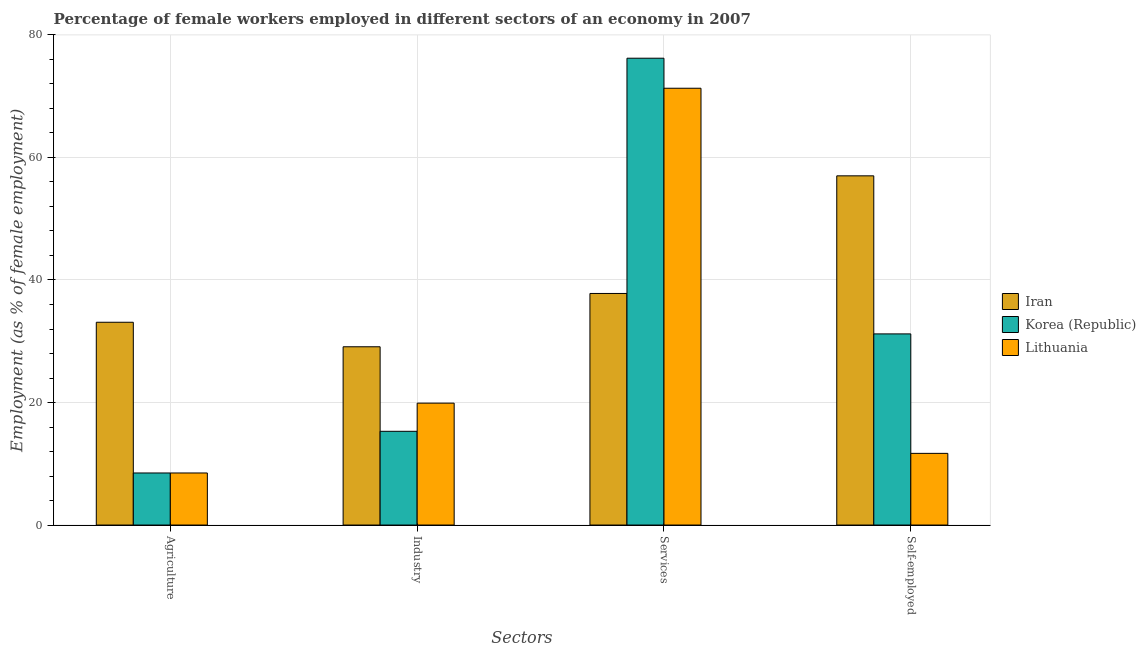How many different coloured bars are there?
Your answer should be compact. 3. Are the number of bars per tick equal to the number of legend labels?
Your answer should be compact. Yes. How many bars are there on the 1st tick from the left?
Offer a very short reply. 3. What is the label of the 4th group of bars from the left?
Provide a short and direct response. Self-employed. What is the percentage of female workers in agriculture in Lithuania?
Your response must be concise. 8.5. Across all countries, what is the maximum percentage of female workers in industry?
Offer a very short reply. 29.1. Across all countries, what is the minimum percentage of female workers in agriculture?
Make the answer very short. 8.5. What is the total percentage of female workers in industry in the graph?
Ensure brevity in your answer.  64.3. What is the difference between the percentage of self employed female workers in Korea (Republic) and that in Lithuania?
Offer a very short reply. 19.5. What is the difference between the percentage of female workers in industry in Lithuania and the percentage of female workers in services in Iran?
Make the answer very short. -17.9. What is the average percentage of female workers in industry per country?
Offer a terse response. 21.43. What is the difference between the percentage of female workers in services and percentage of female workers in industry in Korea (Republic)?
Provide a succinct answer. 60.9. What is the ratio of the percentage of female workers in industry in Lithuania to that in Iran?
Give a very brief answer. 0.68. What is the difference between the highest and the second highest percentage of female workers in industry?
Keep it short and to the point. 9.2. What is the difference between the highest and the lowest percentage of self employed female workers?
Your response must be concise. 45.3. Is the sum of the percentage of self employed female workers in Iran and Lithuania greater than the maximum percentage of female workers in agriculture across all countries?
Your response must be concise. Yes. Is it the case that in every country, the sum of the percentage of self employed female workers and percentage of female workers in industry is greater than the sum of percentage of female workers in agriculture and percentage of female workers in services?
Your answer should be very brief. No. What does the 1st bar from the left in Industry represents?
Keep it short and to the point. Iran. What does the 1st bar from the right in Services represents?
Give a very brief answer. Lithuania. Is it the case that in every country, the sum of the percentage of female workers in agriculture and percentage of female workers in industry is greater than the percentage of female workers in services?
Give a very brief answer. No. How many bars are there?
Offer a terse response. 12. How many countries are there in the graph?
Make the answer very short. 3. What is the difference between two consecutive major ticks on the Y-axis?
Ensure brevity in your answer.  20. Does the graph contain any zero values?
Offer a terse response. No. Where does the legend appear in the graph?
Keep it short and to the point. Center right. How many legend labels are there?
Your answer should be very brief. 3. How are the legend labels stacked?
Your response must be concise. Vertical. What is the title of the graph?
Offer a terse response. Percentage of female workers employed in different sectors of an economy in 2007. What is the label or title of the X-axis?
Provide a short and direct response. Sectors. What is the label or title of the Y-axis?
Offer a terse response. Employment (as % of female employment). What is the Employment (as % of female employment) in Iran in Agriculture?
Give a very brief answer. 33.1. What is the Employment (as % of female employment) of Korea (Republic) in Agriculture?
Give a very brief answer. 8.5. What is the Employment (as % of female employment) in Iran in Industry?
Keep it short and to the point. 29.1. What is the Employment (as % of female employment) in Korea (Republic) in Industry?
Your answer should be very brief. 15.3. What is the Employment (as % of female employment) of Lithuania in Industry?
Provide a succinct answer. 19.9. What is the Employment (as % of female employment) in Iran in Services?
Your answer should be compact. 37.8. What is the Employment (as % of female employment) in Korea (Republic) in Services?
Your response must be concise. 76.2. What is the Employment (as % of female employment) in Lithuania in Services?
Give a very brief answer. 71.3. What is the Employment (as % of female employment) of Iran in Self-employed?
Give a very brief answer. 57. What is the Employment (as % of female employment) in Korea (Republic) in Self-employed?
Your answer should be very brief. 31.2. What is the Employment (as % of female employment) in Lithuania in Self-employed?
Give a very brief answer. 11.7. Across all Sectors, what is the maximum Employment (as % of female employment) of Korea (Republic)?
Your answer should be very brief. 76.2. Across all Sectors, what is the maximum Employment (as % of female employment) of Lithuania?
Offer a very short reply. 71.3. Across all Sectors, what is the minimum Employment (as % of female employment) of Iran?
Give a very brief answer. 29.1. Across all Sectors, what is the minimum Employment (as % of female employment) of Lithuania?
Provide a short and direct response. 8.5. What is the total Employment (as % of female employment) in Iran in the graph?
Offer a terse response. 157. What is the total Employment (as % of female employment) in Korea (Republic) in the graph?
Your answer should be very brief. 131.2. What is the total Employment (as % of female employment) of Lithuania in the graph?
Offer a terse response. 111.4. What is the difference between the Employment (as % of female employment) of Iran in Agriculture and that in Industry?
Ensure brevity in your answer.  4. What is the difference between the Employment (as % of female employment) of Korea (Republic) in Agriculture and that in Industry?
Provide a succinct answer. -6.8. What is the difference between the Employment (as % of female employment) in Iran in Agriculture and that in Services?
Provide a short and direct response. -4.7. What is the difference between the Employment (as % of female employment) of Korea (Republic) in Agriculture and that in Services?
Offer a terse response. -67.7. What is the difference between the Employment (as % of female employment) in Lithuania in Agriculture and that in Services?
Provide a succinct answer. -62.8. What is the difference between the Employment (as % of female employment) of Iran in Agriculture and that in Self-employed?
Your response must be concise. -23.9. What is the difference between the Employment (as % of female employment) of Korea (Republic) in Agriculture and that in Self-employed?
Provide a succinct answer. -22.7. What is the difference between the Employment (as % of female employment) of Lithuania in Agriculture and that in Self-employed?
Ensure brevity in your answer.  -3.2. What is the difference between the Employment (as % of female employment) of Korea (Republic) in Industry and that in Services?
Your response must be concise. -60.9. What is the difference between the Employment (as % of female employment) of Lithuania in Industry and that in Services?
Offer a very short reply. -51.4. What is the difference between the Employment (as % of female employment) in Iran in Industry and that in Self-employed?
Provide a succinct answer. -27.9. What is the difference between the Employment (as % of female employment) of Korea (Republic) in Industry and that in Self-employed?
Provide a short and direct response. -15.9. What is the difference between the Employment (as % of female employment) in Iran in Services and that in Self-employed?
Provide a succinct answer. -19.2. What is the difference between the Employment (as % of female employment) of Lithuania in Services and that in Self-employed?
Provide a succinct answer. 59.6. What is the difference between the Employment (as % of female employment) in Iran in Agriculture and the Employment (as % of female employment) in Lithuania in Industry?
Your answer should be very brief. 13.2. What is the difference between the Employment (as % of female employment) of Korea (Republic) in Agriculture and the Employment (as % of female employment) of Lithuania in Industry?
Keep it short and to the point. -11.4. What is the difference between the Employment (as % of female employment) of Iran in Agriculture and the Employment (as % of female employment) of Korea (Republic) in Services?
Offer a terse response. -43.1. What is the difference between the Employment (as % of female employment) of Iran in Agriculture and the Employment (as % of female employment) of Lithuania in Services?
Provide a short and direct response. -38.2. What is the difference between the Employment (as % of female employment) of Korea (Republic) in Agriculture and the Employment (as % of female employment) of Lithuania in Services?
Provide a short and direct response. -62.8. What is the difference between the Employment (as % of female employment) in Iran in Agriculture and the Employment (as % of female employment) in Lithuania in Self-employed?
Make the answer very short. 21.4. What is the difference between the Employment (as % of female employment) in Iran in Industry and the Employment (as % of female employment) in Korea (Republic) in Services?
Your answer should be compact. -47.1. What is the difference between the Employment (as % of female employment) in Iran in Industry and the Employment (as % of female employment) in Lithuania in Services?
Your answer should be compact. -42.2. What is the difference between the Employment (as % of female employment) in Korea (Republic) in Industry and the Employment (as % of female employment) in Lithuania in Services?
Make the answer very short. -56. What is the difference between the Employment (as % of female employment) in Iran in Industry and the Employment (as % of female employment) in Korea (Republic) in Self-employed?
Provide a short and direct response. -2.1. What is the difference between the Employment (as % of female employment) in Iran in Services and the Employment (as % of female employment) in Lithuania in Self-employed?
Your answer should be very brief. 26.1. What is the difference between the Employment (as % of female employment) in Korea (Republic) in Services and the Employment (as % of female employment) in Lithuania in Self-employed?
Offer a very short reply. 64.5. What is the average Employment (as % of female employment) of Iran per Sectors?
Ensure brevity in your answer.  39.25. What is the average Employment (as % of female employment) of Korea (Republic) per Sectors?
Offer a very short reply. 32.8. What is the average Employment (as % of female employment) of Lithuania per Sectors?
Provide a short and direct response. 27.85. What is the difference between the Employment (as % of female employment) of Iran and Employment (as % of female employment) of Korea (Republic) in Agriculture?
Give a very brief answer. 24.6. What is the difference between the Employment (as % of female employment) of Iran and Employment (as % of female employment) of Lithuania in Agriculture?
Keep it short and to the point. 24.6. What is the difference between the Employment (as % of female employment) in Korea (Republic) and Employment (as % of female employment) in Lithuania in Industry?
Offer a very short reply. -4.6. What is the difference between the Employment (as % of female employment) of Iran and Employment (as % of female employment) of Korea (Republic) in Services?
Give a very brief answer. -38.4. What is the difference between the Employment (as % of female employment) in Iran and Employment (as % of female employment) in Lithuania in Services?
Provide a short and direct response. -33.5. What is the difference between the Employment (as % of female employment) in Korea (Republic) and Employment (as % of female employment) in Lithuania in Services?
Provide a short and direct response. 4.9. What is the difference between the Employment (as % of female employment) in Iran and Employment (as % of female employment) in Korea (Republic) in Self-employed?
Your response must be concise. 25.8. What is the difference between the Employment (as % of female employment) of Iran and Employment (as % of female employment) of Lithuania in Self-employed?
Make the answer very short. 45.3. What is the ratio of the Employment (as % of female employment) of Iran in Agriculture to that in Industry?
Your answer should be compact. 1.14. What is the ratio of the Employment (as % of female employment) in Korea (Republic) in Agriculture to that in Industry?
Provide a succinct answer. 0.56. What is the ratio of the Employment (as % of female employment) of Lithuania in Agriculture to that in Industry?
Ensure brevity in your answer.  0.43. What is the ratio of the Employment (as % of female employment) in Iran in Agriculture to that in Services?
Offer a terse response. 0.88. What is the ratio of the Employment (as % of female employment) in Korea (Republic) in Agriculture to that in Services?
Ensure brevity in your answer.  0.11. What is the ratio of the Employment (as % of female employment) in Lithuania in Agriculture to that in Services?
Your answer should be very brief. 0.12. What is the ratio of the Employment (as % of female employment) of Iran in Agriculture to that in Self-employed?
Make the answer very short. 0.58. What is the ratio of the Employment (as % of female employment) of Korea (Republic) in Agriculture to that in Self-employed?
Offer a very short reply. 0.27. What is the ratio of the Employment (as % of female employment) of Lithuania in Agriculture to that in Self-employed?
Your answer should be compact. 0.73. What is the ratio of the Employment (as % of female employment) of Iran in Industry to that in Services?
Keep it short and to the point. 0.77. What is the ratio of the Employment (as % of female employment) of Korea (Republic) in Industry to that in Services?
Ensure brevity in your answer.  0.2. What is the ratio of the Employment (as % of female employment) in Lithuania in Industry to that in Services?
Your response must be concise. 0.28. What is the ratio of the Employment (as % of female employment) of Iran in Industry to that in Self-employed?
Ensure brevity in your answer.  0.51. What is the ratio of the Employment (as % of female employment) of Korea (Republic) in Industry to that in Self-employed?
Ensure brevity in your answer.  0.49. What is the ratio of the Employment (as % of female employment) in Lithuania in Industry to that in Self-employed?
Offer a very short reply. 1.7. What is the ratio of the Employment (as % of female employment) in Iran in Services to that in Self-employed?
Your answer should be very brief. 0.66. What is the ratio of the Employment (as % of female employment) in Korea (Republic) in Services to that in Self-employed?
Offer a terse response. 2.44. What is the ratio of the Employment (as % of female employment) of Lithuania in Services to that in Self-employed?
Your answer should be compact. 6.09. What is the difference between the highest and the second highest Employment (as % of female employment) in Korea (Republic)?
Offer a very short reply. 45. What is the difference between the highest and the second highest Employment (as % of female employment) of Lithuania?
Keep it short and to the point. 51.4. What is the difference between the highest and the lowest Employment (as % of female employment) in Iran?
Provide a succinct answer. 27.9. What is the difference between the highest and the lowest Employment (as % of female employment) of Korea (Republic)?
Offer a very short reply. 67.7. What is the difference between the highest and the lowest Employment (as % of female employment) of Lithuania?
Provide a succinct answer. 62.8. 